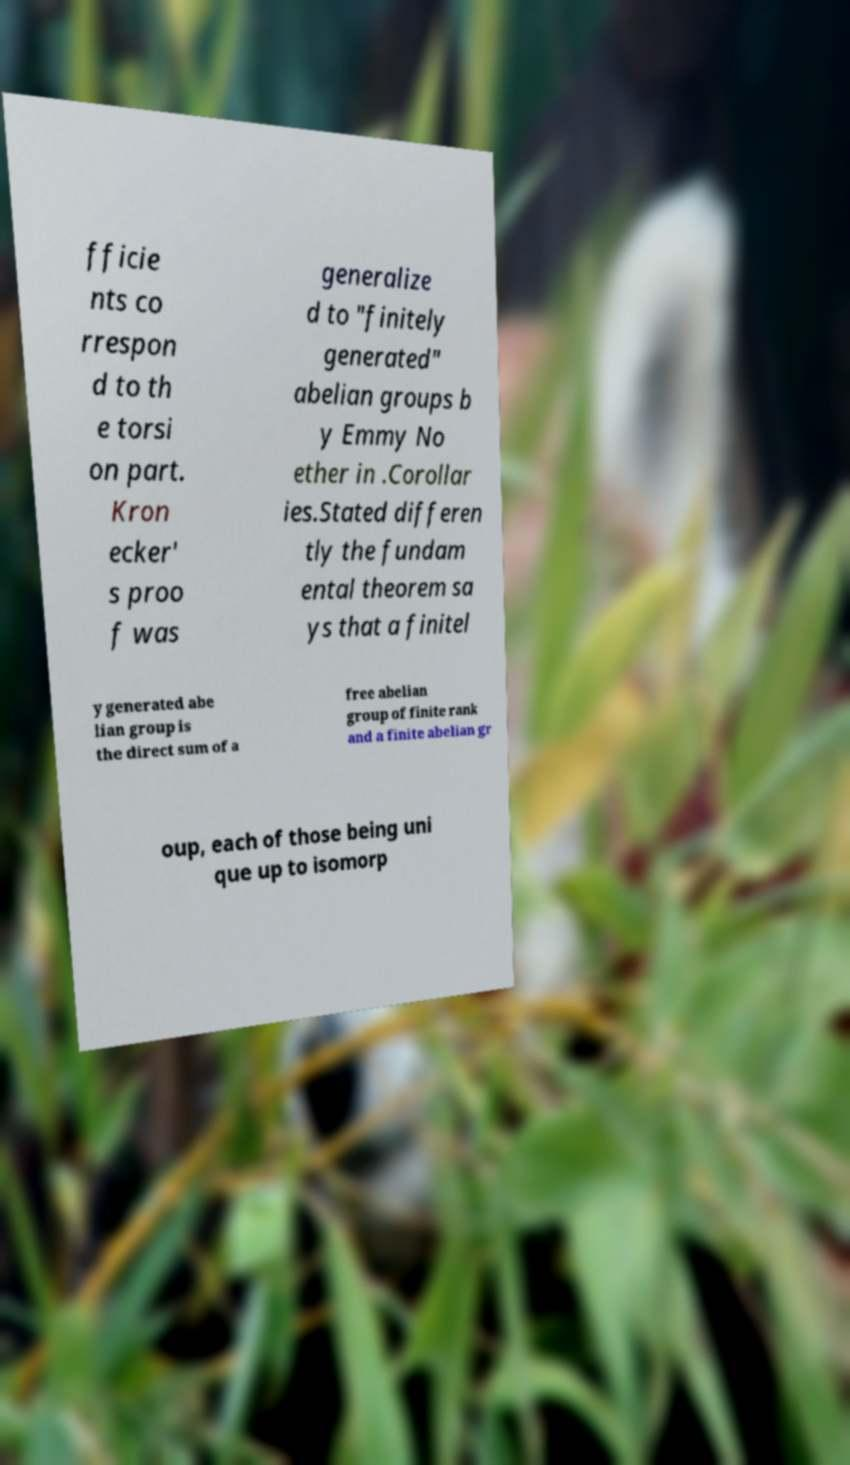Can you accurately transcribe the text from the provided image for me? fficie nts co rrespon d to th e torsi on part. Kron ecker' s proo f was generalize d to "finitely generated" abelian groups b y Emmy No ether in .Corollar ies.Stated differen tly the fundam ental theorem sa ys that a finitel y generated abe lian group is the direct sum of a free abelian group of finite rank and a finite abelian gr oup, each of those being uni que up to isomorp 